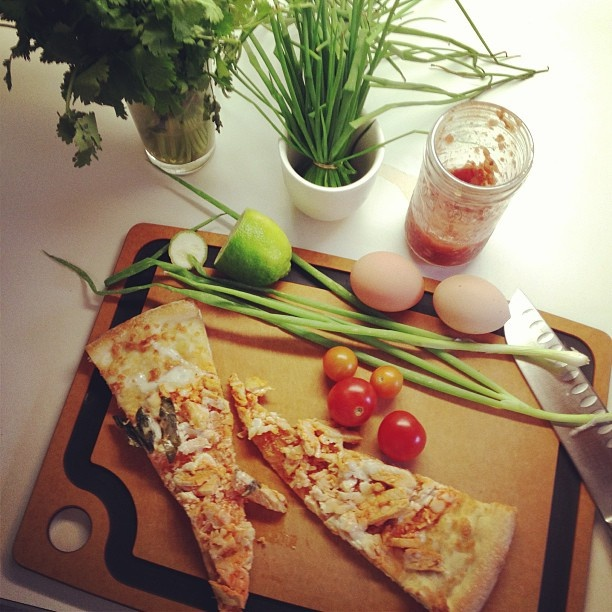Describe the objects in this image and their specific colors. I can see pizza in black, tan, brown, and salmon tones, pizza in black, tan, brown, and salmon tones, cup in black, beige, and tan tones, knife in black, ivory, gray, maroon, and brown tones, and bowl in black, tan, and beige tones in this image. 